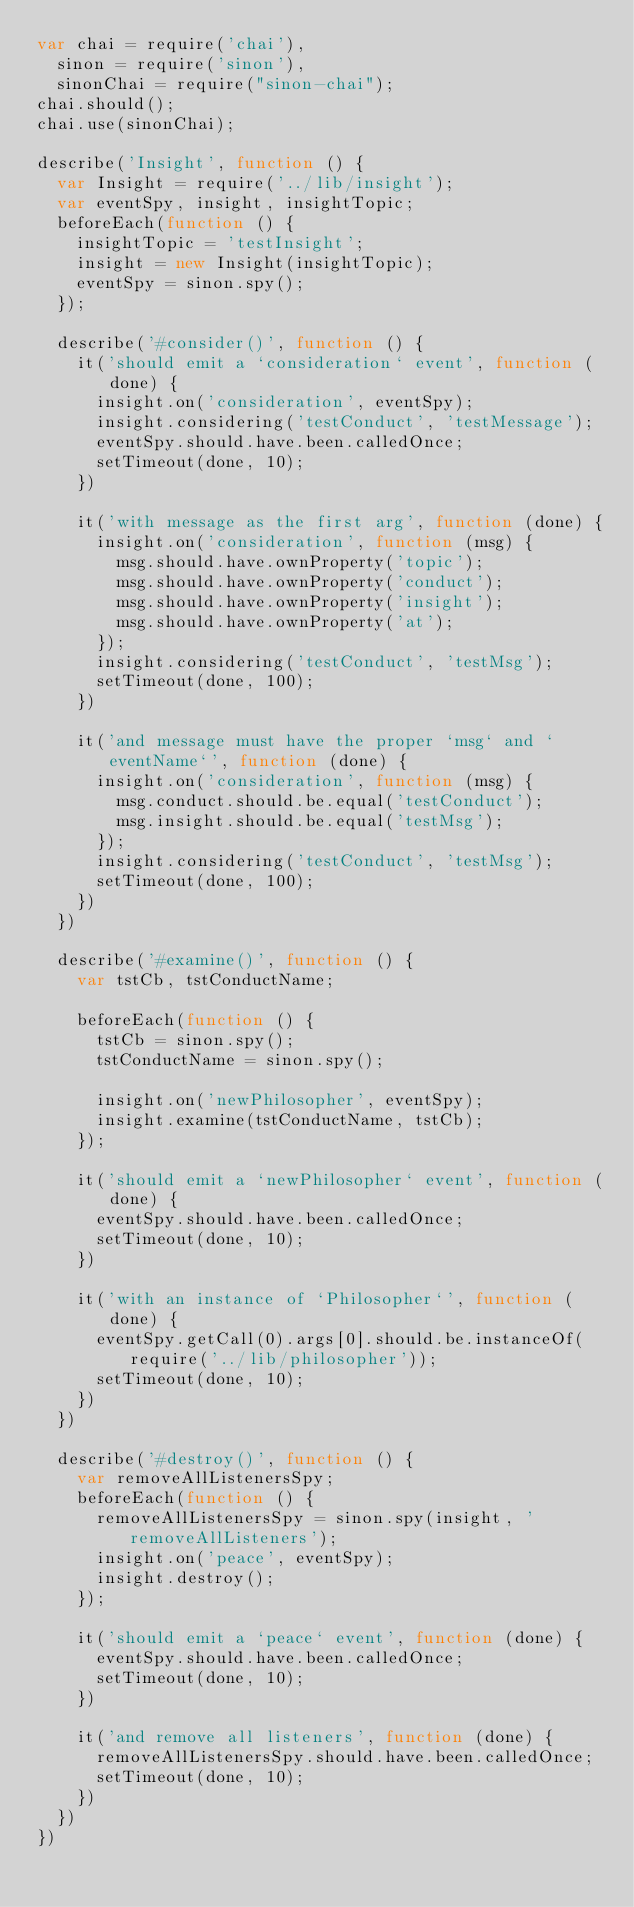Convert code to text. <code><loc_0><loc_0><loc_500><loc_500><_JavaScript_>var chai = require('chai'),
  sinon = require('sinon'),
  sinonChai = require("sinon-chai");
chai.should();
chai.use(sinonChai);

describe('Insight', function () {
  var Insight = require('../lib/insight');
  var eventSpy, insight, insightTopic;
  beforeEach(function () {
    insightTopic = 'testInsight';
    insight = new Insight(insightTopic);
    eventSpy = sinon.spy();
  });

  describe('#consider()', function () {
    it('should emit a `consideration` event', function (done) {
      insight.on('consideration', eventSpy);
      insight.considering('testConduct', 'testMessage');
      eventSpy.should.have.been.calledOnce;
      setTimeout(done, 10);
    })

    it('with message as the first arg', function (done) {
      insight.on('consideration', function (msg) {
        msg.should.have.ownProperty('topic');
        msg.should.have.ownProperty('conduct');
        msg.should.have.ownProperty('insight');
        msg.should.have.ownProperty('at');
      });
      insight.considering('testConduct', 'testMsg');
      setTimeout(done, 100);
    })

    it('and message must have the proper `msg` and `eventName`', function (done) {
      insight.on('consideration', function (msg) {
        msg.conduct.should.be.equal('testConduct');
        msg.insight.should.be.equal('testMsg');
      });
      insight.considering('testConduct', 'testMsg');
      setTimeout(done, 100);
    })
  })

  describe('#examine()', function () {
    var tstCb, tstConductName;

    beforeEach(function () {
      tstCb = sinon.spy();
      tstConductName = sinon.spy();

      insight.on('newPhilosopher', eventSpy);
      insight.examine(tstConductName, tstCb);
    });

    it('should emit a `newPhilosopher` event', function (done) {
      eventSpy.should.have.been.calledOnce;
      setTimeout(done, 10);
    })

    it('with an instance of `Philosopher`', function (done) {
      eventSpy.getCall(0).args[0].should.be.instanceOf(require('../lib/philosopher'));
      setTimeout(done, 10);
    })
  })

  describe('#destroy()', function () {
    var removeAllListenersSpy;
    beforeEach(function () {
      removeAllListenersSpy = sinon.spy(insight, 'removeAllListeners');
      insight.on('peace', eventSpy);
      insight.destroy();
    });

    it('should emit a `peace` event', function (done) {
      eventSpy.should.have.been.calledOnce;
      setTimeout(done, 10);
    })

    it('and remove all listeners', function (done) {
      removeAllListenersSpy.should.have.been.calledOnce;
      setTimeout(done, 10);
    })
  })
})
</code> 